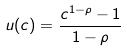Convert formula to latex. <formula><loc_0><loc_0><loc_500><loc_500>u ( c ) = \frac { c ^ { 1 - \rho } - 1 } { 1 - \rho }</formula> 